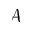<formula> <loc_0><loc_0><loc_500><loc_500>\mathcal { A }</formula> 